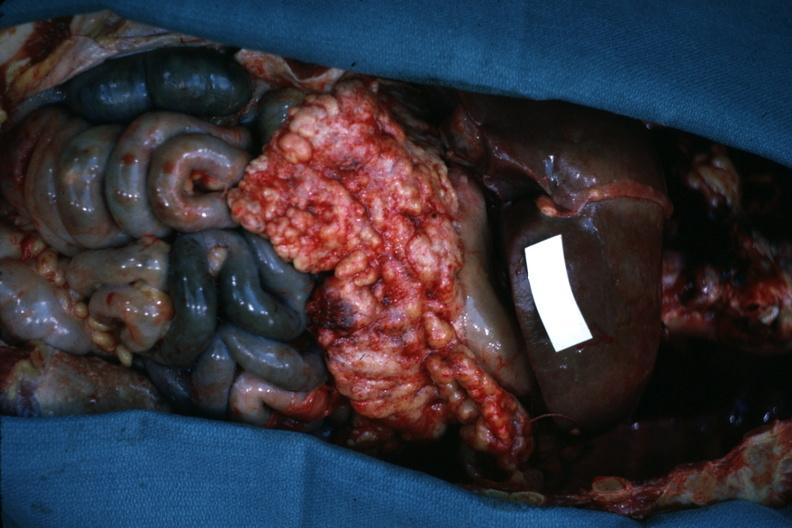what is ischemic?
Answer the question using a single word or phrase. Opened abdominal cavity with massive tumor in omentum none apparent in liver nor over peritoneal surfaces gut 